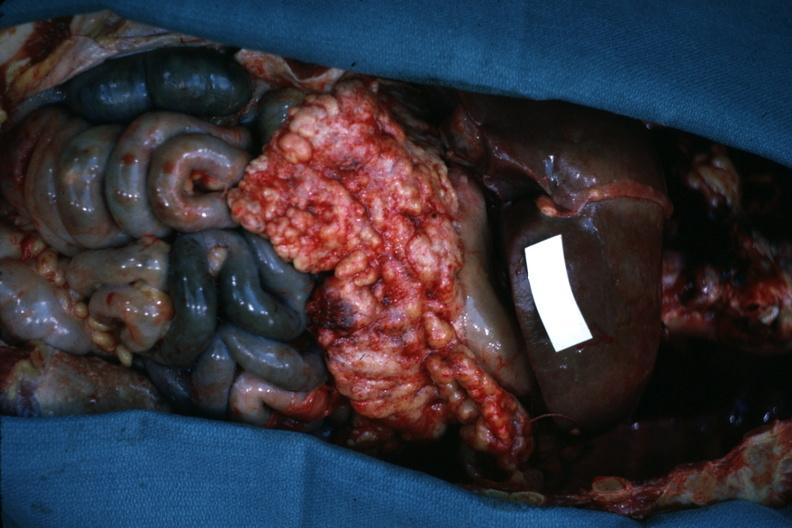what is ischemic?
Answer the question using a single word or phrase. Opened abdominal cavity with massive tumor in omentum none apparent in liver nor over peritoneal surfaces gut 